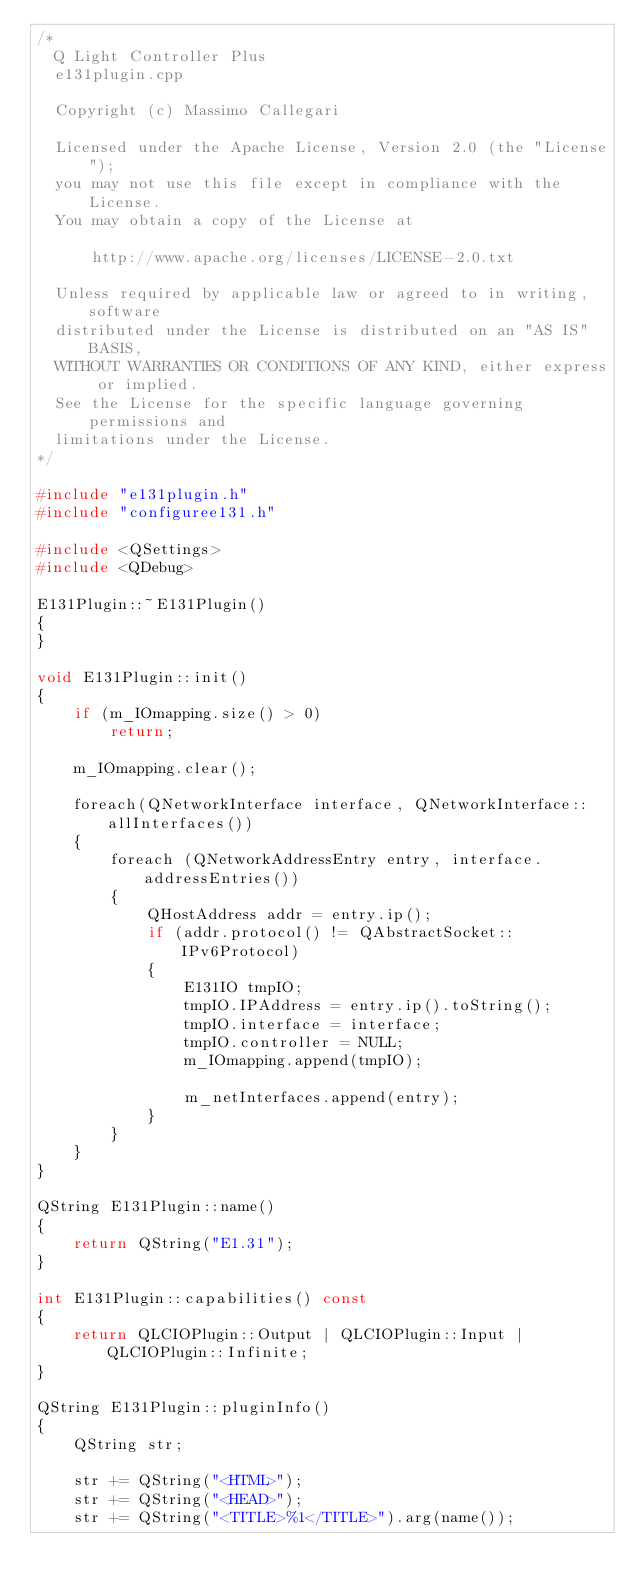<code> <loc_0><loc_0><loc_500><loc_500><_C++_>/*
  Q Light Controller Plus
  e131plugin.cpp

  Copyright (c) Massimo Callegari

  Licensed under the Apache License, Version 2.0 (the "License");
  you may not use this file except in compliance with the License.
  You may obtain a copy of the License at

      http://www.apache.org/licenses/LICENSE-2.0.txt

  Unless required by applicable law or agreed to in writing, software
  distributed under the License is distributed on an "AS IS" BASIS,
  WITHOUT WARRANTIES OR CONDITIONS OF ANY KIND, either express or implied.
  See the License for the specific language governing permissions and
  limitations under the License.
*/

#include "e131plugin.h"
#include "configuree131.h"

#include <QSettings>
#include <QDebug>

E131Plugin::~E131Plugin()
{
}

void E131Plugin::init()
{
    if (m_IOmapping.size() > 0)
        return;

    m_IOmapping.clear();

    foreach(QNetworkInterface interface, QNetworkInterface::allInterfaces())
    {
        foreach (QNetworkAddressEntry entry, interface.addressEntries())
        {
            QHostAddress addr = entry.ip();
            if (addr.protocol() != QAbstractSocket::IPv6Protocol)
            {
                E131IO tmpIO;
                tmpIO.IPAddress = entry.ip().toString();
                tmpIO.interface = interface;
                tmpIO.controller = NULL;
                m_IOmapping.append(tmpIO);

                m_netInterfaces.append(entry);
            }
        }
    }
}

QString E131Plugin::name()
{
    return QString("E1.31");
}

int E131Plugin::capabilities() const
{
    return QLCIOPlugin::Output | QLCIOPlugin::Input | QLCIOPlugin::Infinite;
}

QString E131Plugin::pluginInfo()
{
    QString str;

    str += QString("<HTML>");
    str += QString("<HEAD>");
    str += QString("<TITLE>%1</TITLE>").arg(name());</code> 